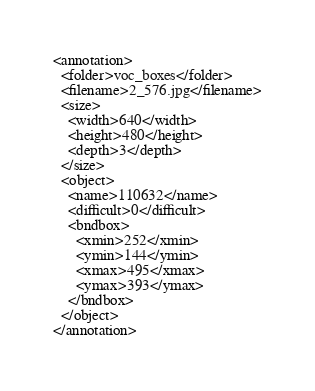<code> <loc_0><loc_0><loc_500><loc_500><_XML_><annotation>
  <folder>voc_boxes</folder>
  <filename>2_576.jpg</filename>
  <size>
    <width>640</width>
    <height>480</height>
    <depth>3</depth>
  </size>
  <object>
    <name>110632</name>
    <difficult>0</difficult>
    <bndbox>
      <xmin>252</xmin>
      <ymin>144</ymin>
      <xmax>495</xmax>
      <ymax>393</ymax>
    </bndbox>
  </object>
</annotation></code> 